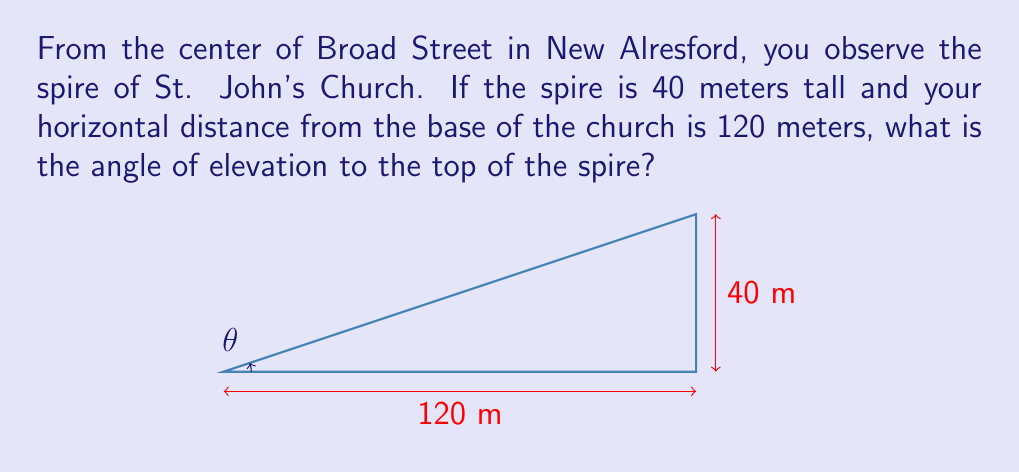Solve this math problem. Let's approach this step-by-step:

1) We can model this situation as a right triangle, where:
   - The horizontal distance forms the base of the triangle
   - The height of the spire forms the vertical side
   - The line of sight to the top of the spire forms the hypotenuse

2) We're looking for the angle of elevation, which is the angle between the horizontal line and the line of sight.

3) In a right triangle, we can find this angle using the tangent function:

   $\tan(\theta) = \frac{\text{opposite}}{\text{adjacent}}$

4) In our case:
   - The opposite side is the height of the spire: 40 meters
   - The adjacent side is the horizontal distance: 120 meters

5) Let's substitute these values:

   $\tan(\theta) = \frac{40}{120} = \frac{1}{3}$

6) To find $\theta$, we need to use the inverse tangent function (also called arctangent):

   $\theta = \tan^{-1}(\frac{1}{3})$

7) Using a calculator or computer:

   $\theta \approx 18.43^\circ$

8) Round to two decimal places:

   $\theta \approx 18.43^\circ$
Answer: $18.43^\circ$ 